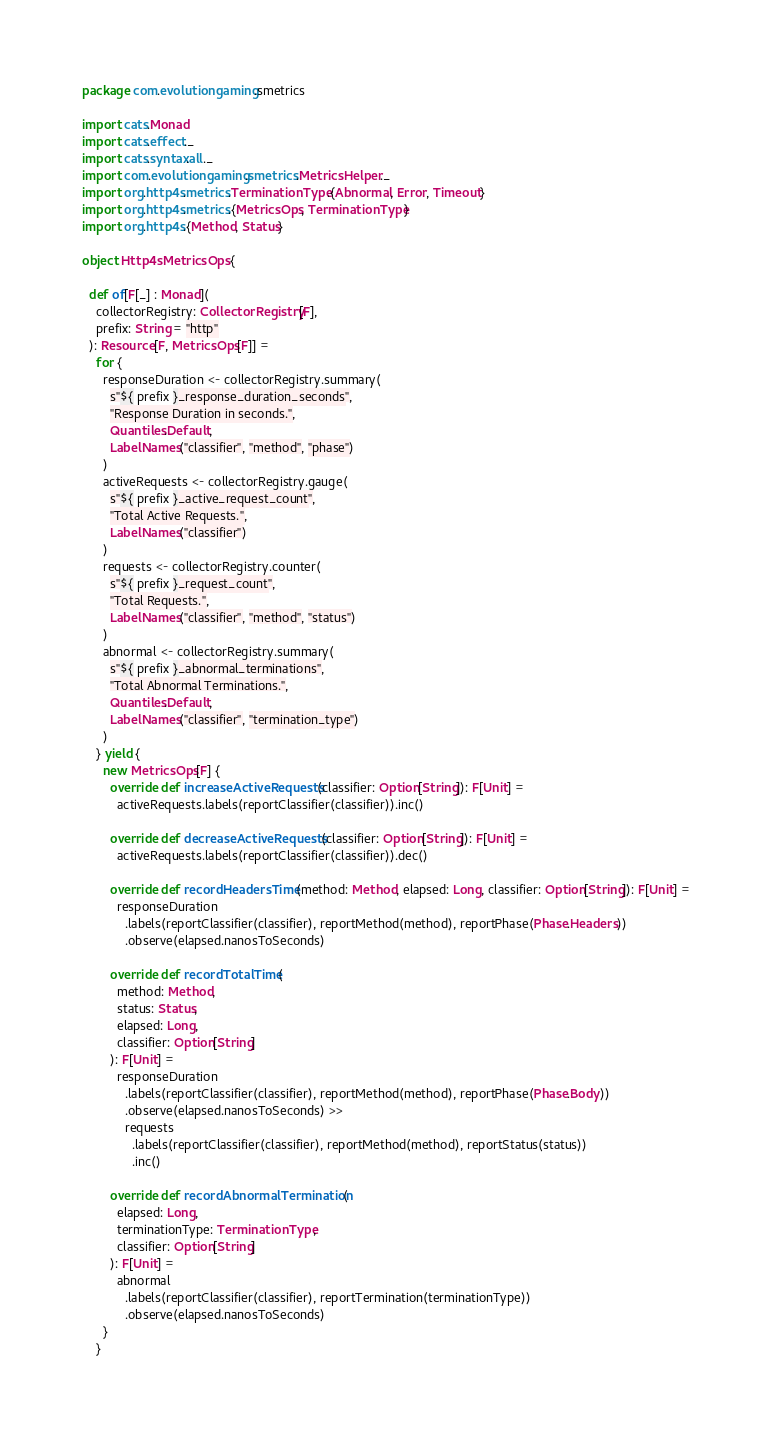Convert code to text. <code><loc_0><loc_0><loc_500><loc_500><_Scala_>package com.evolutiongaming.smetrics

import cats.Monad
import cats.effect._
import cats.syntax.all._
import com.evolutiongaming.smetrics.MetricsHelper._
import org.http4s.metrics.TerminationType.{Abnormal, Error, Timeout}
import org.http4s.metrics.{MetricsOps, TerminationType}
import org.http4s.{Method, Status}

object Http4sMetricsOps {

  def of[F[_] : Monad](
    collectorRegistry: CollectorRegistry[F],
    prefix: String = "http"
  ): Resource[F, MetricsOps[F]] =
    for {
      responseDuration <- collectorRegistry.summary(
        s"${ prefix }_response_duration_seconds",
        "Response Duration in seconds.",
        Quantiles.Default,
        LabelNames("classifier", "method", "phase")
      )
      activeRequests <- collectorRegistry.gauge(
        s"${ prefix }_active_request_count",
        "Total Active Requests.",
        LabelNames("classifier")
      )
      requests <- collectorRegistry.counter(
        s"${ prefix }_request_count",
        "Total Requests.",
        LabelNames("classifier", "method", "status")
      )
      abnormal <- collectorRegistry.summary(
        s"${ prefix }_abnormal_terminations",
        "Total Abnormal Terminations.",
        Quantiles.Default,
        LabelNames("classifier", "termination_type")
      )
    } yield {
      new MetricsOps[F] {
        override def increaseActiveRequests(classifier: Option[String]): F[Unit] =
          activeRequests.labels(reportClassifier(classifier)).inc()

        override def decreaseActiveRequests(classifier: Option[String]): F[Unit] =
          activeRequests.labels(reportClassifier(classifier)).dec()

        override def recordHeadersTime(method: Method, elapsed: Long, classifier: Option[String]): F[Unit] =
          responseDuration
            .labels(reportClassifier(classifier), reportMethod(method), reportPhase(Phase.Headers))
            .observe(elapsed.nanosToSeconds)

        override def recordTotalTime(
          method: Method,
          status: Status,
          elapsed: Long,
          classifier: Option[String]
        ): F[Unit] =
          responseDuration
            .labels(reportClassifier(classifier), reportMethod(method), reportPhase(Phase.Body))
            .observe(elapsed.nanosToSeconds) >>
            requests
              .labels(reportClassifier(classifier), reportMethod(method), reportStatus(status))
              .inc()

        override def recordAbnormalTermination(
          elapsed: Long,
          terminationType: TerminationType,
          classifier: Option[String]
        ): F[Unit] =
          abnormal
            .labels(reportClassifier(classifier), reportTermination(terminationType))
            .observe(elapsed.nanosToSeconds)
      }
    }
</code> 